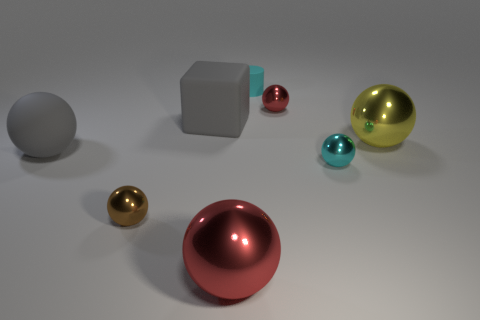Are there any other things that are the same shape as the cyan rubber thing?
Make the answer very short. No. There is a big ball in front of the large gray matte sphere; does it have the same color as the metallic object that is behind the big gray matte block?
Give a very brief answer. Yes. What number of cyan objects are there?
Provide a short and direct response. 2. How many red objects are behind the gray ball and in front of the brown metallic sphere?
Ensure brevity in your answer.  0. Is there a large gray block made of the same material as the tiny brown object?
Your answer should be very brief. No. What material is the cyan thing that is in front of the big gray matte thing in front of the large matte block?
Provide a succinct answer. Metal. Are there an equal number of small brown metal spheres that are on the right side of the tiny red thing and tiny red shiny balls that are on the right side of the tiny cyan shiny ball?
Give a very brief answer. Yes. Is the shape of the tiny cyan shiny object the same as the cyan rubber thing?
Provide a short and direct response. No. The thing that is both to the left of the tiny cyan cylinder and behind the yellow object is made of what material?
Keep it short and to the point. Rubber. What number of tiny brown things are the same shape as the cyan metal object?
Your response must be concise. 1. 